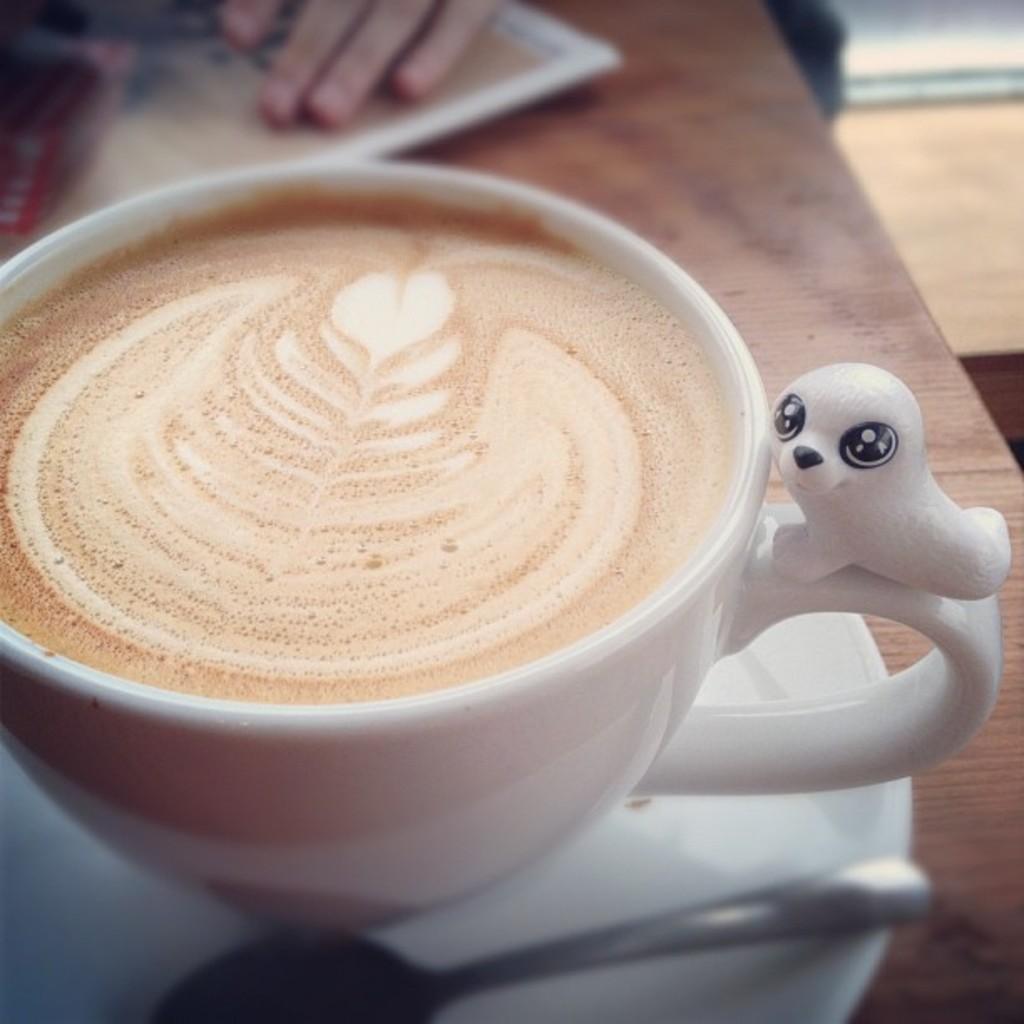Can you describe this image briefly? In the picture there is a coffee cup kept on a table. 